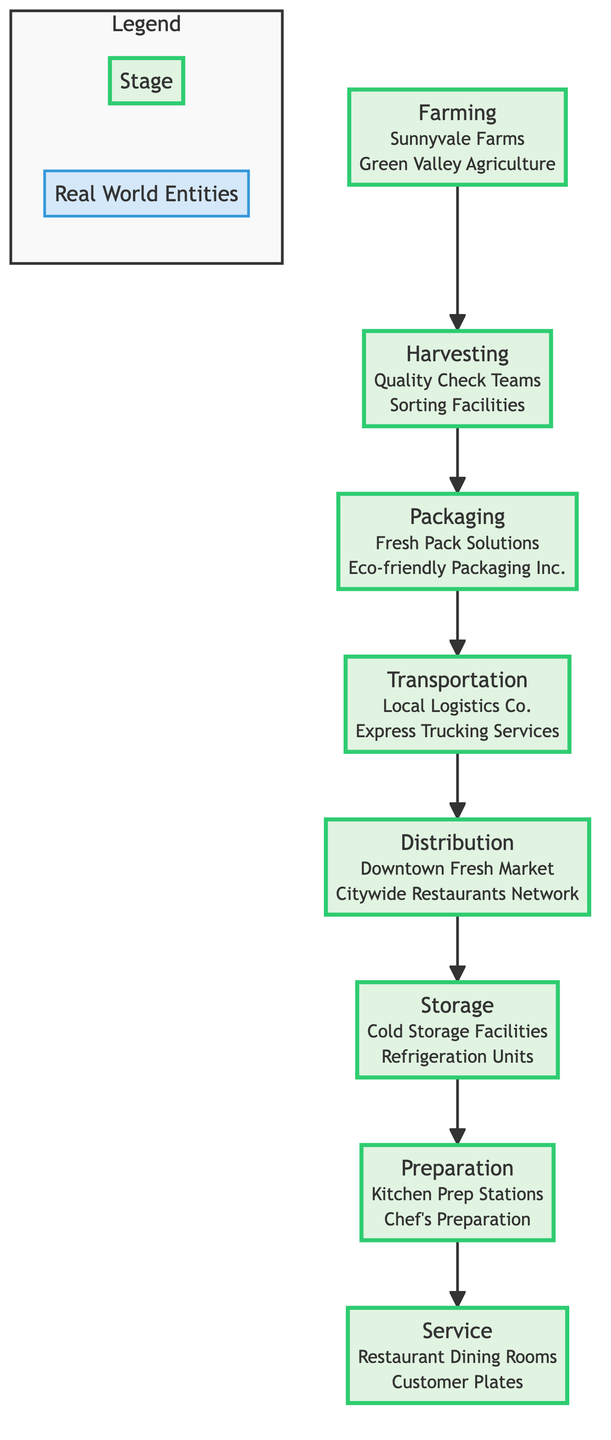What is the first stage in the process? The first stage, or bottom-most stage in the flow chart, is Farming, which involves local farmers growing and harvesting fresh produce.
Answer: Farming What real-world entities are involved in the Harvesting stage? The Harvesting stage includes Quality Check Teams and Sorting Facilities, as indicated in the description provided in the diagram.
Answer: Quality Check Teams, Sorting Facilities How many stages are there in total? The flow chart illustrates a total of eight distinct stages in the supply chain process for fresh produce, from Farming to Service.
Answer: Eight Which stage comes immediately after Packaging? According to the flow chart, the Packaging stage is followed by the Transportation stage, where the packaged produce is transported to local markets and restaurants.
Answer: Transportation What is the purpose of the Storage stage? The Storage stage is meant for storing received produce in temperature-controlled environments to maintain freshness before it is prepared for use.
Answer: Temperature-controlled environments Which stage precedes Preparation? Preparation follows the Storage stage, as indicated by the direction of the arrows in the flow chart representing the flow of the supply chain process.
Answer: Storage What type of facilities are associated with the Service stage? The Service stage is linked to Restaurant Dining Rooms and Customer Plates, which represent where prepared produce is served to customers.
Answer: Restaurant Dining Rooms, Customer Plates What entity is associated with the Distribution stage? The Distribution stage is associated with entities like Downtown Fresh Market and Citywide Restaurants Network, which helps in distributing the produce to various retailers and restaurants.
Answer: Downtown Fresh Market, Citywide Restaurants Network What do we understand by the term "Preparation" in this process? The term "Preparation" refers to the stage where the produce is prepped for use in restaurant kitchens, ensuring it's ready to be cooked and served.
Answer: Prepped for use in restaurant kitchens 